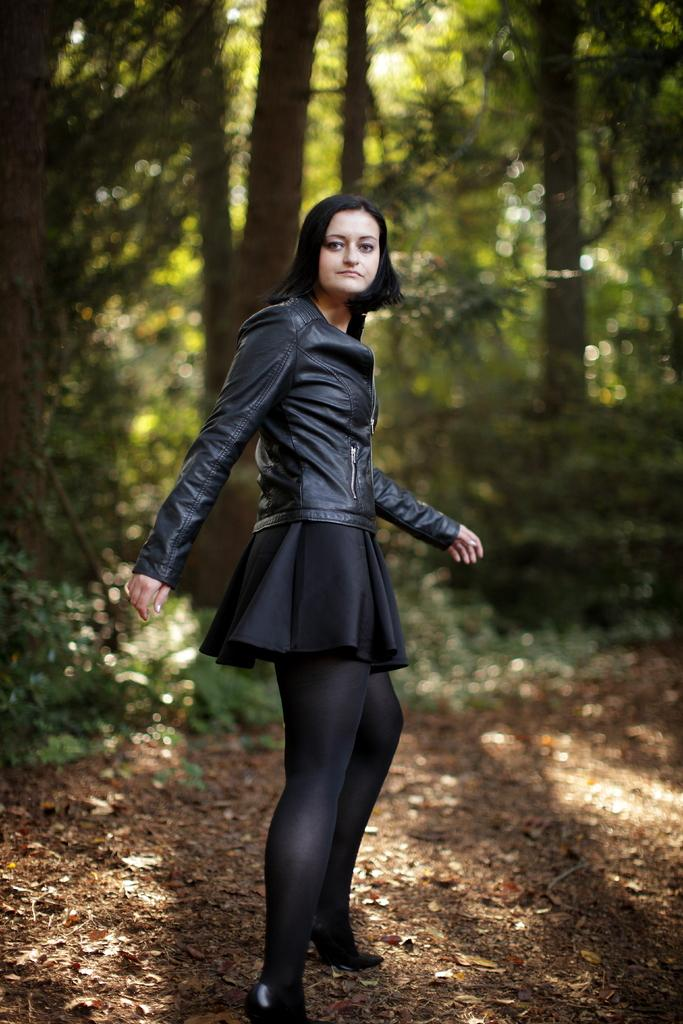What is the main subject of the image? There is a woman standing in the middle of the image. What is the woman doing in the image? The woman is watching something. What can be seen in the background of the image? There are trees visible behind the woman. How many lizards can be seen balancing on the route in the image? There are no lizards or routes visible in the image. 